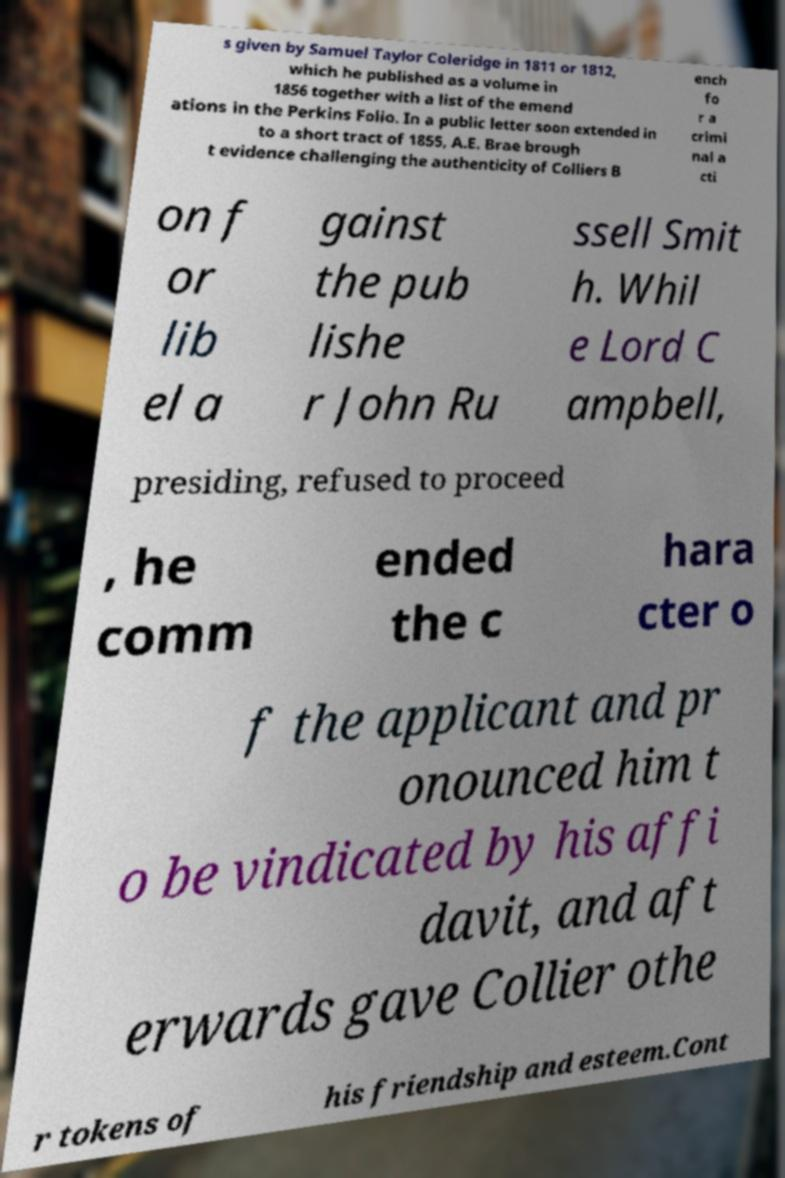Could you assist in decoding the text presented in this image and type it out clearly? s given by Samuel Taylor Coleridge in 1811 or 1812, which he published as a volume in 1856 together with a list of the emend ations in the Perkins Folio. In a public letter soon extended in to a short tract of 1855, A.E. Brae brough t evidence challenging the authenticity of Colliers B ench fo r a crimi nal a cti on f or lib el a gainst the pub lishe r John Ru ssell Smit h. Whil e Lord C ampbell, presiding, refused to proceed , he comm ended the c hara cter o f the applicant and pr onounced him t o be vindicated by his affi davit, and aft erwards gave Collier othe r tokens of his friendship and esteem.Cont 